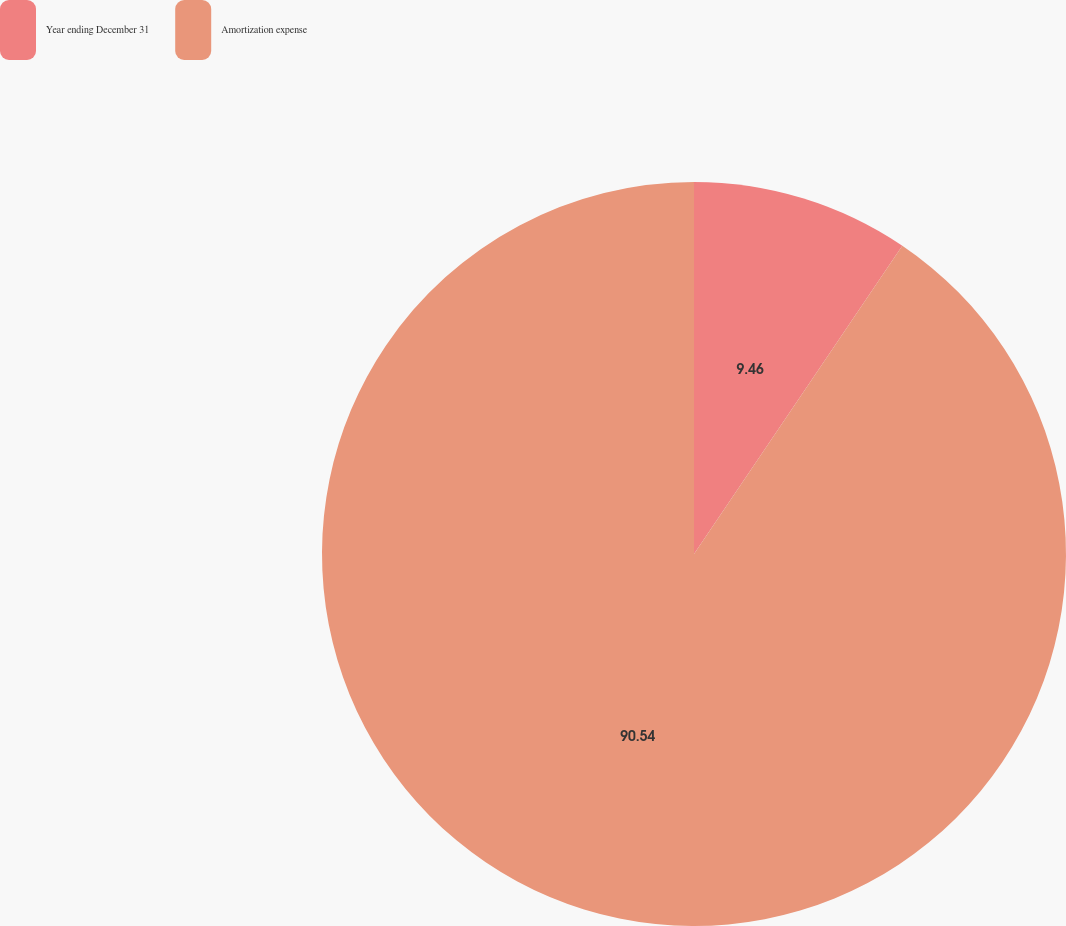Convert chart to OTSL. <chart><loc_0><loc_0><loc_500><loc_500><pie_chart><fcel>Year ending December 31<fcel>Amortization expense<nl><fcel>9.46%<fcel>90.54%<nl></chart> 